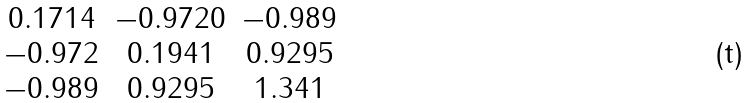Convert formula to latex. <formula><loc_0><loc_0><loc_500><loc_500>\begin{matrix} 0 . 1 7 1 4 & - 0 . 9 7 2 0 & - 0 . 9 8 9 \\ - 0 . 9 7 2 & 0 . 1 9 4 1 & 0 . 9 2 9 5 \\ - 0 . 9 8 9 & 0 . 9 2 9 5 & 1 . 3 4 1 \\ \end{matrix}</formula> 